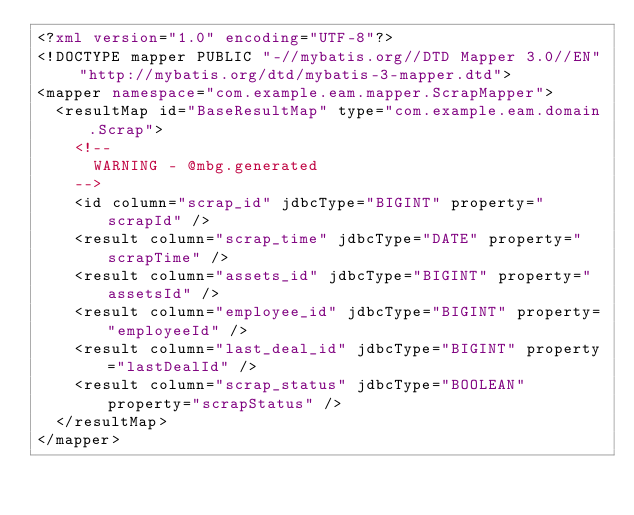<code> <loc_0><loc_0><loc_500><loc_500><_XML_><?xml version="1.0" encoding="UTF-8"?>
<!DOCTYPE mapper PUBLIC "-//mybatis.org//DTD Mapper 3.0//EN" "http://mybatis.org/dtd/mybatis-3-mapper.dtd">
<mapper namespace="com.example.eam.mapper.ScrapMapper">
  <resultMap id="BaseResultMap" type="com.example.eam.domain.Scrap">
    <!--
      WARNING - @mbg.generated
    -->
    <id column="scrap_id" jdbcType="BIGINT" property="scrapId" />
    <result column="scrap_time" jdbcType="DATE" property="scrapTime" />
    <result column="assets_id" jdbcType="BIGINT" property="assetsId" />
    <result column="employee_id" jdbcType="BIGINT" property="employeeId" />
    <result column="last_deal_id" jdbcType="BIGINT" property="lastDealId" />
    <result column="scrap_status" jdbcType="BOOLEAN" property="scrapStatus" />
  </resultMap>
</mapper>
</code> 